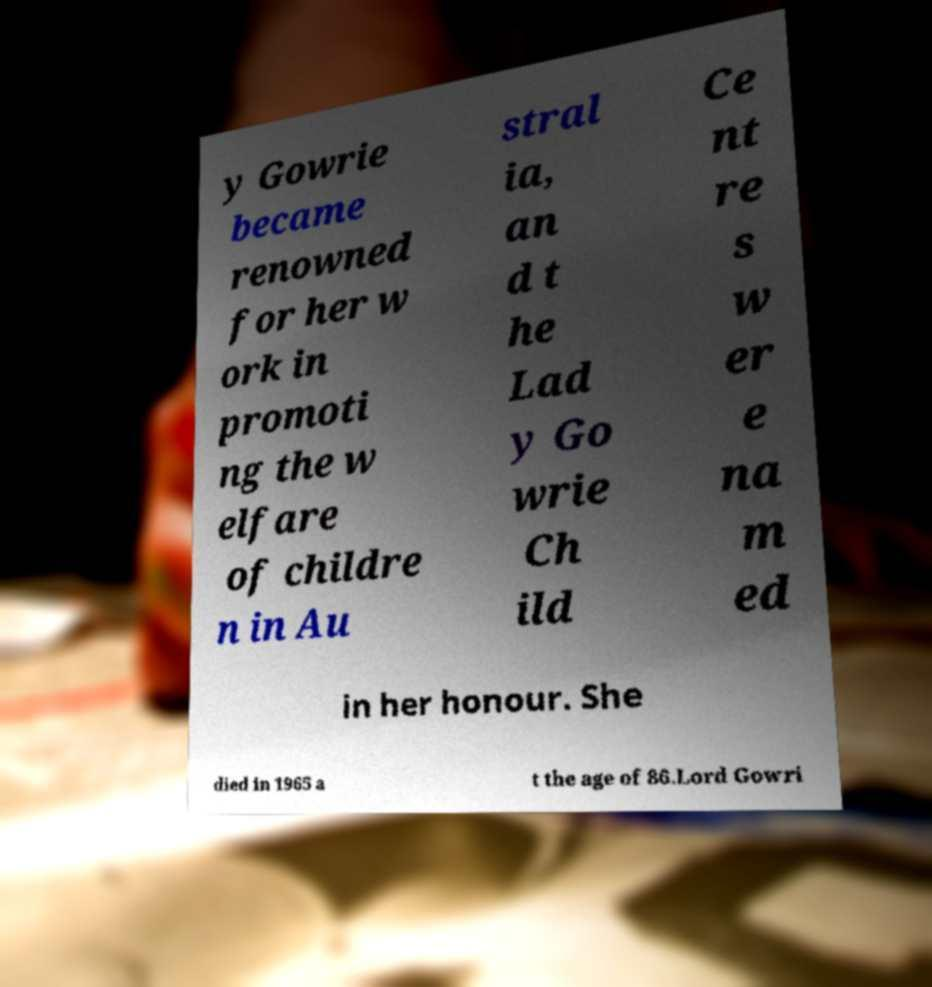I need the written content from this picture converted into text. Can you do that? y Gowrie became renowned for her w ork in promoti ng the w elfare of childre n in Au stral ia, an d t he Lad y Go wrie Ch ild Ce nt re s w er e na m ed in her honour. She died in 1965 a t the age of 86.Lord Gowri 